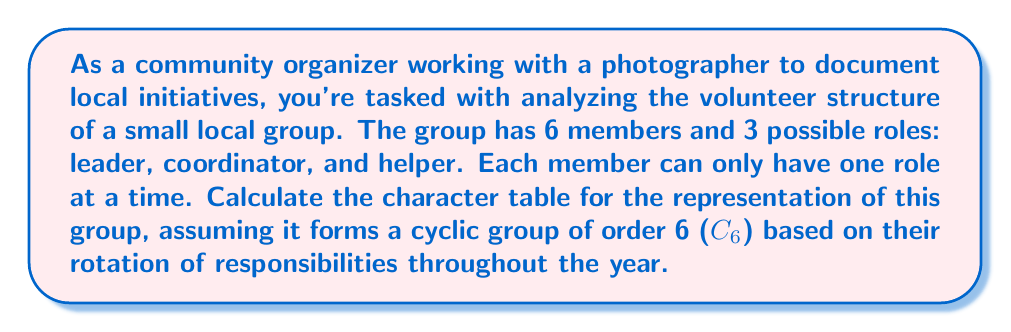Can you answer this question? To calculate the character table for the representation of this local volunteer group, we'll follow these steps:

1) First, recall that for a cyclic group C6, there are 6 conjugacy classes, each containing one element. Let's denote the generator of the group as $a$, so the elements are $\{e, a, a^2, a^3, a^4, a^5\}$.

2) The irreducible representations of C6 are all one-dimensional, and there are 6 of them. We can denote them as $\rho_k$ where $k = 0, 1, 2, 3, 4, 5$.

3) The character of the $k$-th representation on the element $a^j$ is given by:

   $$\chi_k(a^j) = e^{2\pi i kj/6} = (\omega^k)^j$$

   where $\omega = e^{2\pi i/6}$ is a primitive 6th root of unity.

4) Now, let's construct the character table:

   $$\begin{array}{c|cccccc}
      & e & a & a^2 & a^3 & a^4 & a^5 \\
   \hline
   \rho_0 & 1 & 1 & 1 & 1 & 1 & 1 \\
   \rho_1 & 1 & \omega & \omega^2 & \omega^3 & \omega^4 & \omega^5 \\
   \rho_2 & 1 & \omega^2 & \omega^4 & 1 & \omega^2 & \omega^4 \\
   \rho_3 & 1 & \omega^3 & 1 & \omega^3 & 1 & \omega^3 \\
   \rho_4 & 1 & \omega^4 & \omega^2 & 1 & \omega^4 & \omega^2 \\
   \rho_5 & 1 & \omega^5 & \omega^4 & \omega^3 & \omega^2 & \omega
   \end{array}$$

5) We can simplify this further by noting that $\omega^3 = -1$, $\omega^2 = \frac{1}{2}(-1+i\sqrt{3})$, and $\omega^4 = \frac{1}{2}(-1-i\sqrt{3})$.

6) The final character table then becomes:

   $$\begin{array}{c|cccccc}
      & e & a & a^2 & a^3 & a^4 & a^5 \\
   \hline
   \rho_0 & 1 & 1 & 1 & 1 & 1 & 1 \\
   \rho_1 & 1 & \omega & -\frac{1}{2}+i\frac{\sqrt{3}}{2} & -1 & -\frac{1}{2}-i\frac{\sqrt{3}}{2} & \omega^5 \\
   \rho_2 & 1 & -\frac{1}{2}+i\frac{\sqrt{3}}{2} & -\frac{1}{2}-i\frac{\sqrt{3}}{2} & 1 & -\frac{1}{2}+i\frac{\sqrt{3}}{2} & -\frac{1}{2}-i\frac{\sqrt{3}}{2} \\
   \rho_3 & 1 & -1 & 1 & -1 & 1 & -1 \\
   \rho_4 & 1 & -\frac{1}{2}-i\frac{\sqrt{3}}{2} & -\frac{1}{2}+i\frac{\sqrt{3}}{2} & 1 & -\frac{1}{2}-i\frac{\sqrt{3}}{2} & -\frac{1}{2}+i\frac{\sqrt{3}}{2} \\
   \rho_5 & 1 & \omega^5 & -\frac{1}{2}-i\frac{\sqrt{3}}{2} & -1 & -\frac{1}{2}+i\frac{\sqrt{3}}{2} & \omega
   \end{array}$$

This character table represents the irreducible representations of the volunteer group's structure, viewed as a cyclic group of order 6.
Answer: $$\begin{array}{c|cccccc}
   & e & a & a^2 & a^3 & a^4 & a^5 \\
\hline
\rho_0 & 1 & 1 & 1 & 1 & 1 & 1 \\
\rho_1 & 1 & \omega & -\frac{1}{2}+i\frac{\sqrt{3}}{2} & -1 & -\frac{1}{2}-i\frac{\sqrt{3}}{2} & \omega^5 \\
\rho_2 & 1 & -\frac{1}{2}+i\frac{\sqrt{3}}{2} & -\frac{1}{2}-i\frac{\sqrt{3}}{2} & 1 & -\frac{1}{2}+i\frac{\sqrt{3}}{2} & -\frac{1}{2}-i\frac{\sqrt{3}}{2} \\
\rho_3 & 1 & -1 & 1 & -1 & 1 & -1 \\
\rho_4 & 1 & -\frac{1}{2}-i\frac{\sqrt{3}}{2} & -\frac{1}{2}+i\frac{\sqrt{3}}{2} & 1 & -\frac{1}{2}-i\frac{\sqrt{3}}{2} & -\frac{1}{2}+i\frac{\sqrt{3}}{2} \\
\rho_5 & 1 & \omega^5 & -\frac{1}{2}-i\frac{\sqrt{3}}{2} & -1 & -\frac{1}{2}+i\frac{\sqrt{3}}{2} & \omega
\end{array}$$ 